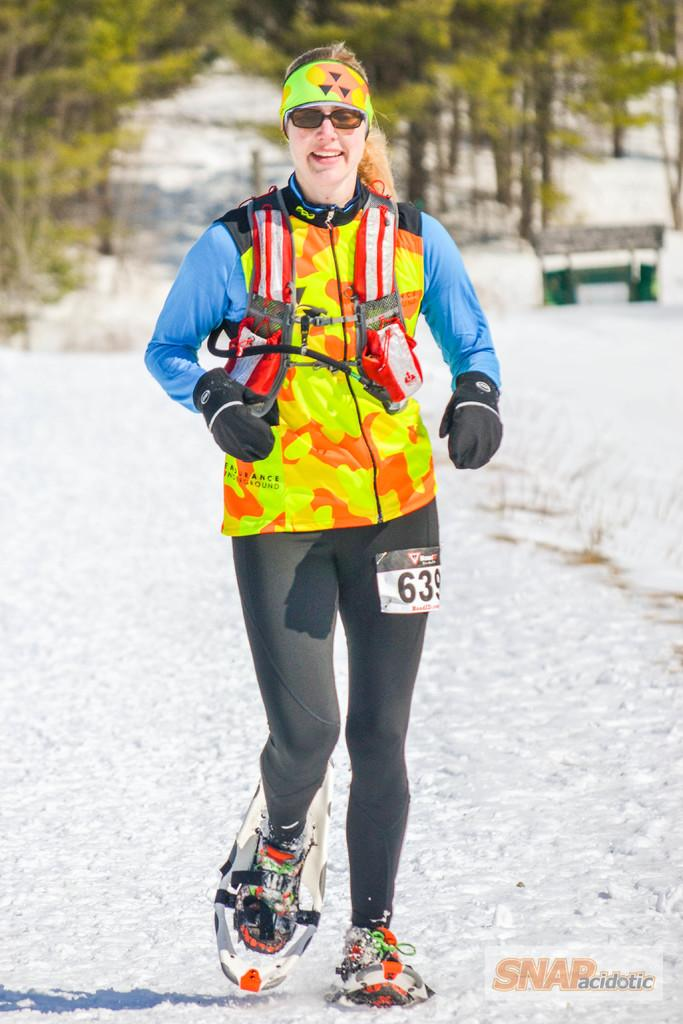Who is the main subject in the image? There is a woman in the image. What is the woman doing in the image? The woman is walking on the snow. What can be seen in the background of the image? There is a bench and trees in the background of the image. Can you see the woman kissing someone in the image? No, there is no indication of a kiss or another person in the image. 